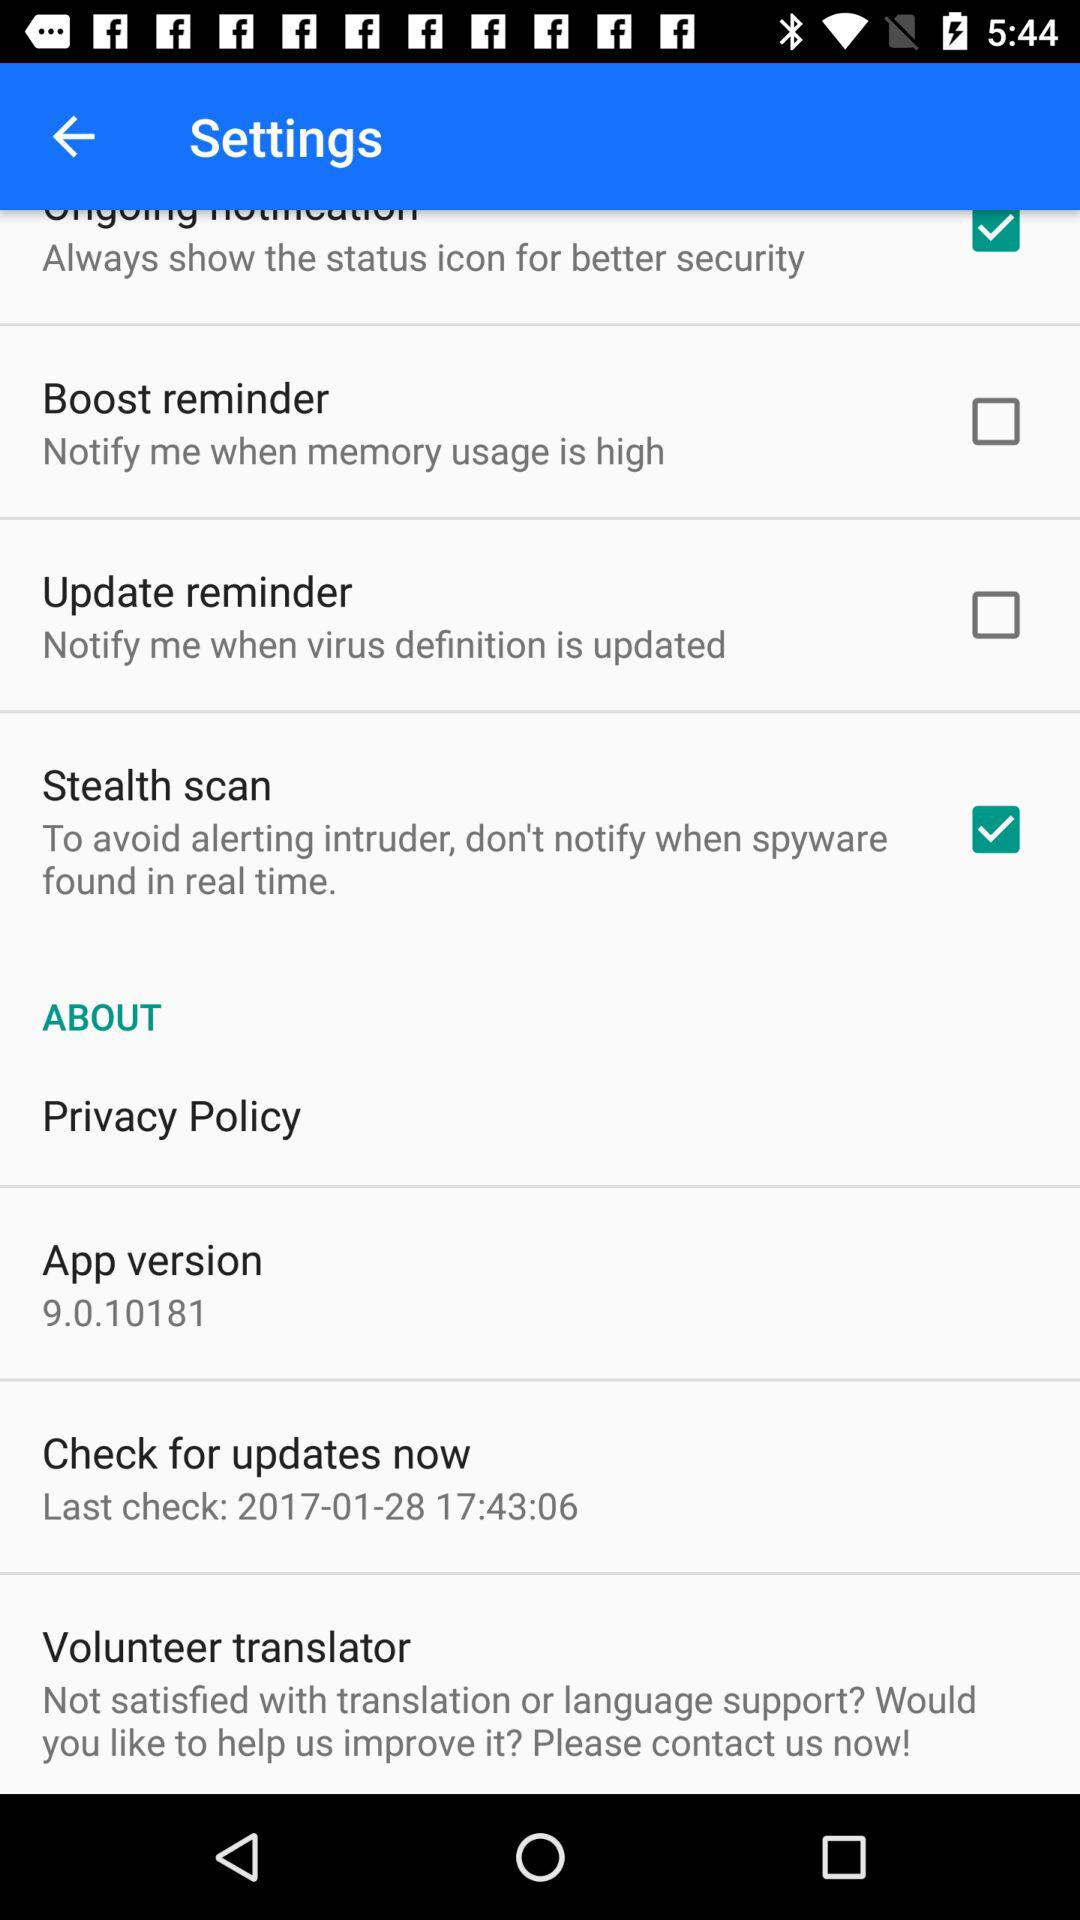What is the date of the last check? The date of the last check is January 28, 2017. 